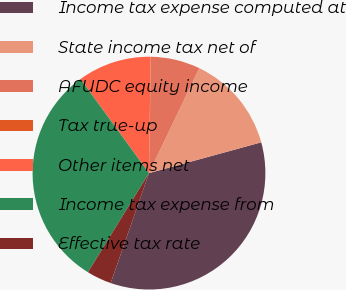<chart> <loc_0><loc_0><loc_500><loc_500><pie_chart><fcel>Income tax expense computed at<fcel>State income tax net of<fcel>AFUDC equity income<fcel>Tax true-up<fcel>Other items net<fcel>Income tax expense from<fcel>Effective tax rate<nl><fcel>34.6%<fcel>13.63%<fcel>6.84%<fcel>0.05%<fcel>10.24%<fcel>31.2%<fcel>3.45%<nl></chart> 